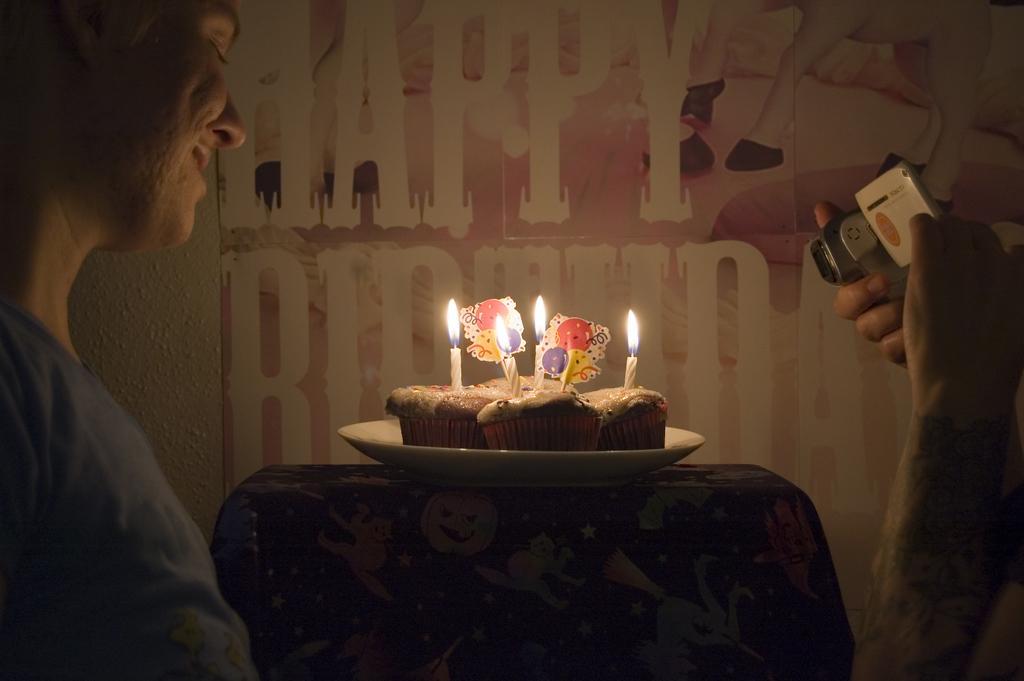Could you give a brief overview of what you see in this image? In this image, I can see the cupcakes with candles on a plate, which is placed on an object. On the left side of the image, I can see a person. On the right side of the image, I can see a person's hand holding a camera. In the background, this is a poster attached to the wall. 